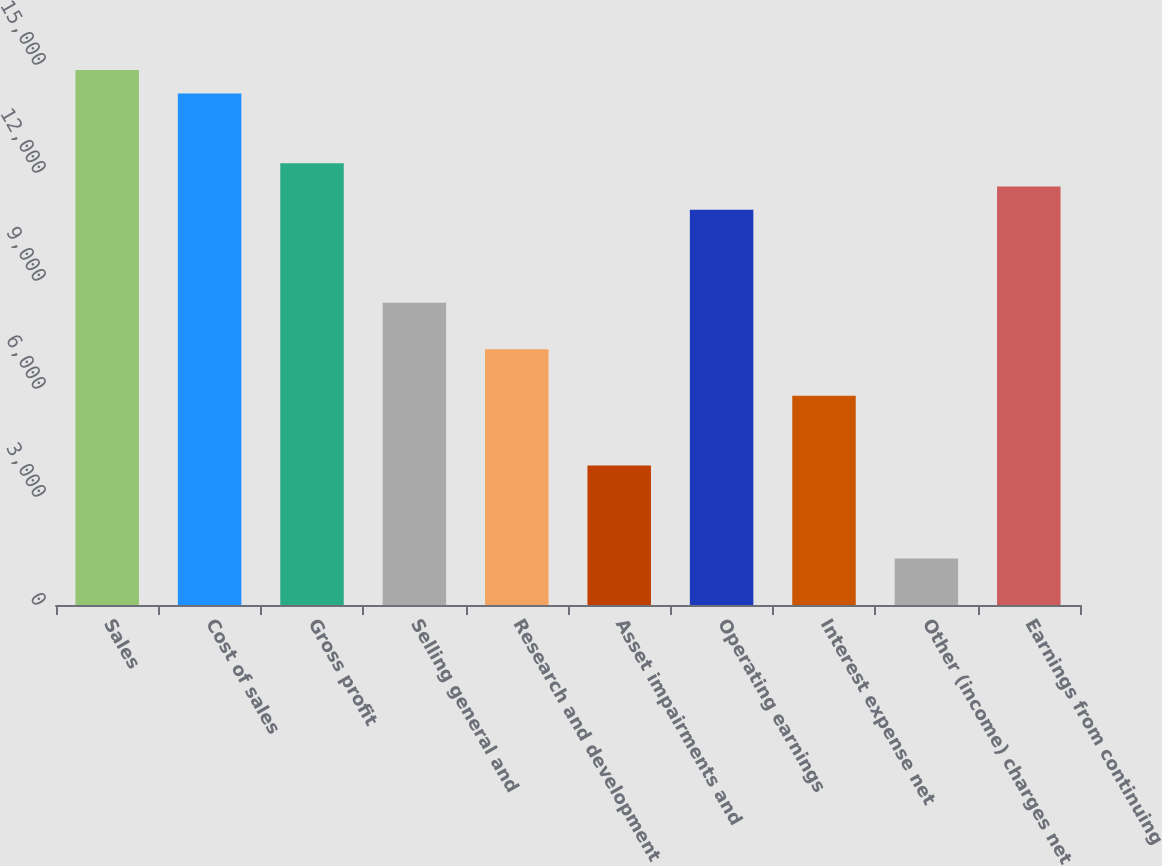Convert chart to OTSL. <chart><loc_0><loc_0><loc_500><loc_500><bar_chart><fcel>Sales<fcel>Cost of sales<fcel>Gross profit<fcel>Selling general and<fcel>Research and development<fcel>Asset impairments and<fcel>Operating earnings<fcel>Interest expense net<fcel>Other (income) charges net<fcel>Earnings from continuing<nl><fcel>14857.7<fcel>14211.8<fcel>12273.8<fcel>8397.94<fcel>7105.98<fcel>3876.08<fcel>10981.9<fcel>5814.02<fcel>1292.16<fcel>11627.8<nl></chart> 